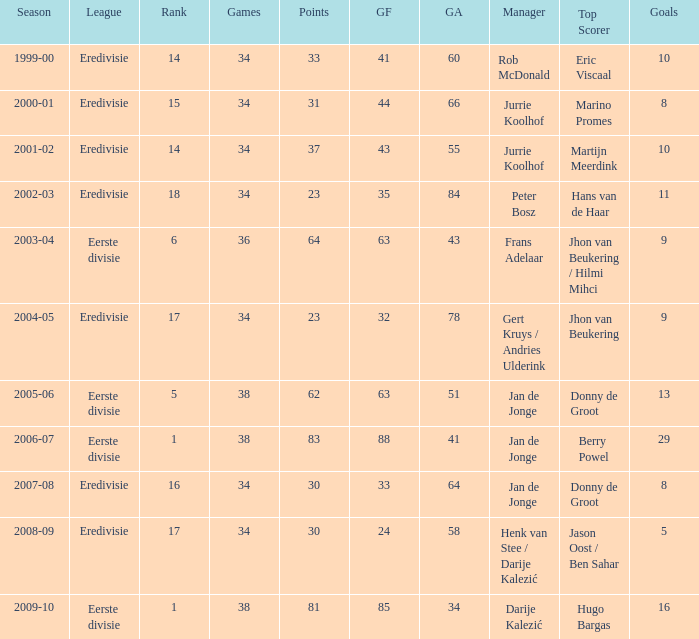Who is the manager whose rank is 16? Jan de Jonge. 